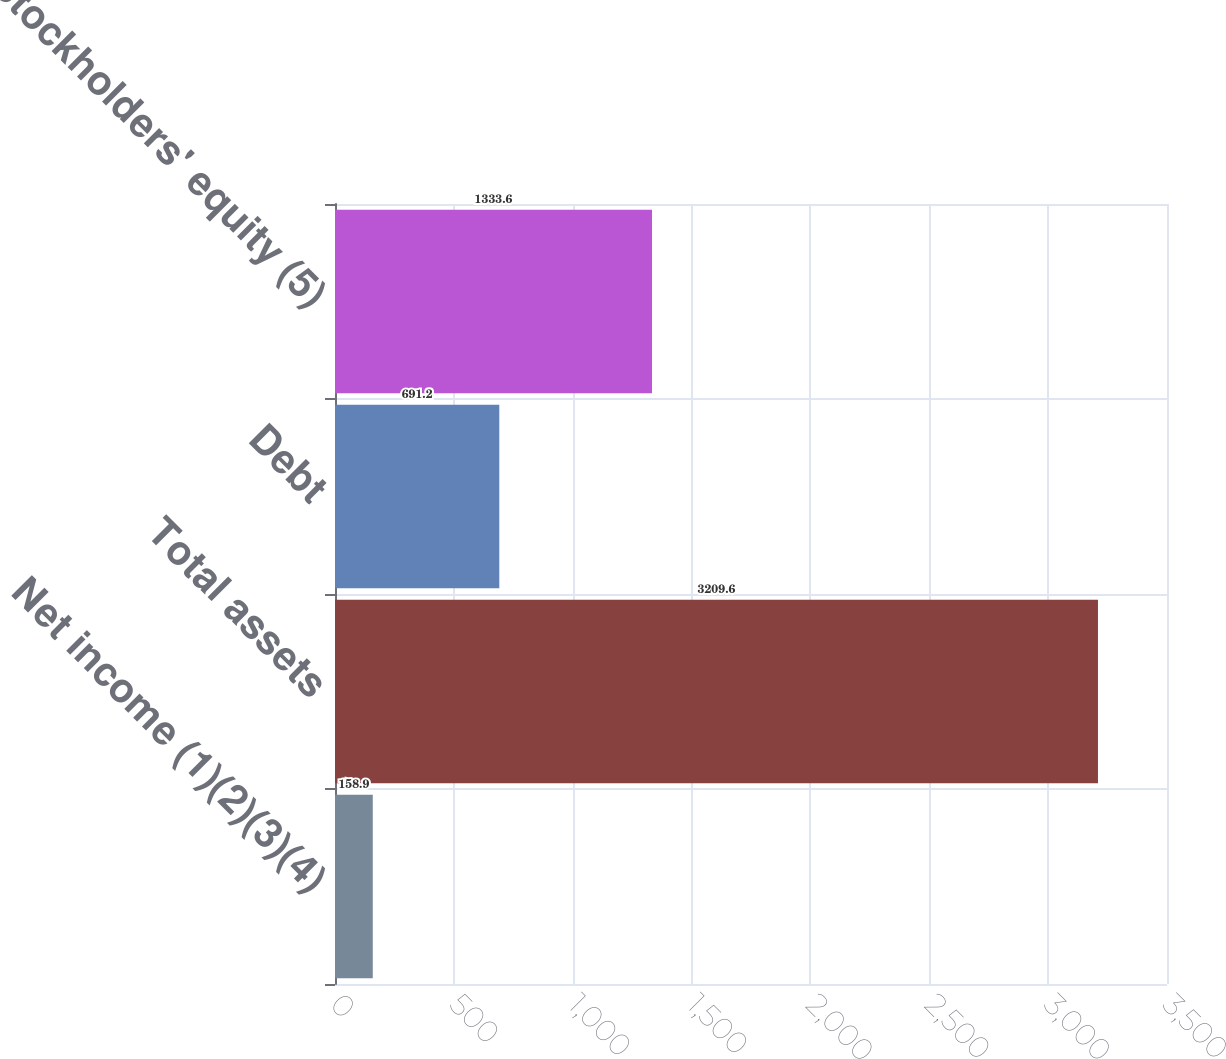Convert chart to OTSL. <chart><loc_0><loc_0><loc_500><loc_500><bar_chart><fcel>Net income (1)(2)(3)(4)<fcel>Total assets<fcel>Debt<fcel>Stockholders' equity (5)<nl><fcel>158.9<fcel>3209.6<fcel>691.2<fcel>1333.6<nl></chart> 